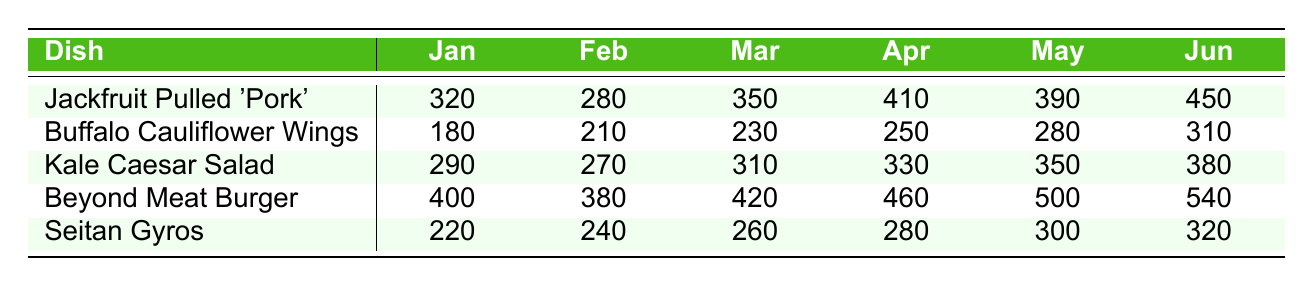What was the highest sales amount recorded for the Beyond Meat Burger? Looking at the sales figures for the Beyond Meat Burger across the months, the maximum value is 540, which is observed in June.
Answer: 540 Which dish had the lowest sales in February? In February, the sales amounts for each dish are: Jackfruit Pulled 'Pork' (280), Buffalo Cauliflower Wings (210), Kale Caesar Salad (270), Beyond Meat Burger (380), and Seitan Gyros (240). The lowest value is 210 from the Buffalo Cauliflower Wings.
Answer: Buffalo Cauliflower Wings What is the total sales of Kale Caesar Salad for the first quarter (January to March)? To find the total sales for Kale Caesar Salad from January (290), February (270), and March (310), we sum these amounts: 290 + 270 + 310 = 870.
Answer: 870 What was the sales difference between the highest and lowest months for Seitan Gyros? The highest sales for Seitan Gyros is in June (320), and the lowest is in January (220). The difference is calculated as: 320 - 220 = 100.
Answer: 100 Is it true that the Jackfruit Pulled 'Pork' Sandwich sold more in April than the Buffalo Cauliflower Wings sold in March? The Jackfruit Pulled 'Pork' Sandwich sold 410 in April, while the Buffalo Cauliflower Wings sold 230 in March. Since 410 is greater than 230, the statement is true.
Answer: Yes What is the average sales per month for the Buffalo Cauliflower Wings? The sales for Buffalo Cauliflower Wings across the six months are 180, 210, 230, 250, 280, and 310. Adding these up gives 180 + 210 + 230 + 250 + 280 + 310 = 1450. Dividing by the number of months, 1450 / 6 = 241.67, which can be rounded to 242.
Answer: 242 Which dish had the highest sales in May, and what was the amount? In May, the sales amounts were: Jackfruit Pulled 'Pork' (390), Buffalo Cauliflower Wings (280), Kale Caesar Salad (350), Beyond Meat Burger (500), and Seitan Gyros (300). The maximum value is 500, which corresponds to the Beyond Meat Burger.
Answer: Beyond Meat Burger, 500 During which month did the Kale Caesar Salad achieve its highest sales? The sales figures for Kale Caesar Salad are 290 in January, 270 in February, 310 in March, 330 in April, 350 in May, and 380 in June. The highest sales is 380, noted in June.
Answer: June What is the overall trend for sales of the Jackfruit Pulled 'Pork' Sandwich from January to June? The sales for Jackfruit Pulled 'Pork' are: 320 (Jan), 280 (Feb), 350 (Mar), 410 (Apr), 390 (May), and 450 (Jun). The trend shows an overall increase from January to June, despite a slight drop from February to March and from April to May.
Answer: Overall increasing trend Which dish was consistently the best-seller across all months? By comparing the sales data, the Beyond Meat Burger has the highest sales figures in every month, ranging from 400 in January to 540 in June. Therefore, it is the consistent best-seller.
Answer: Beyond Meat Burger 